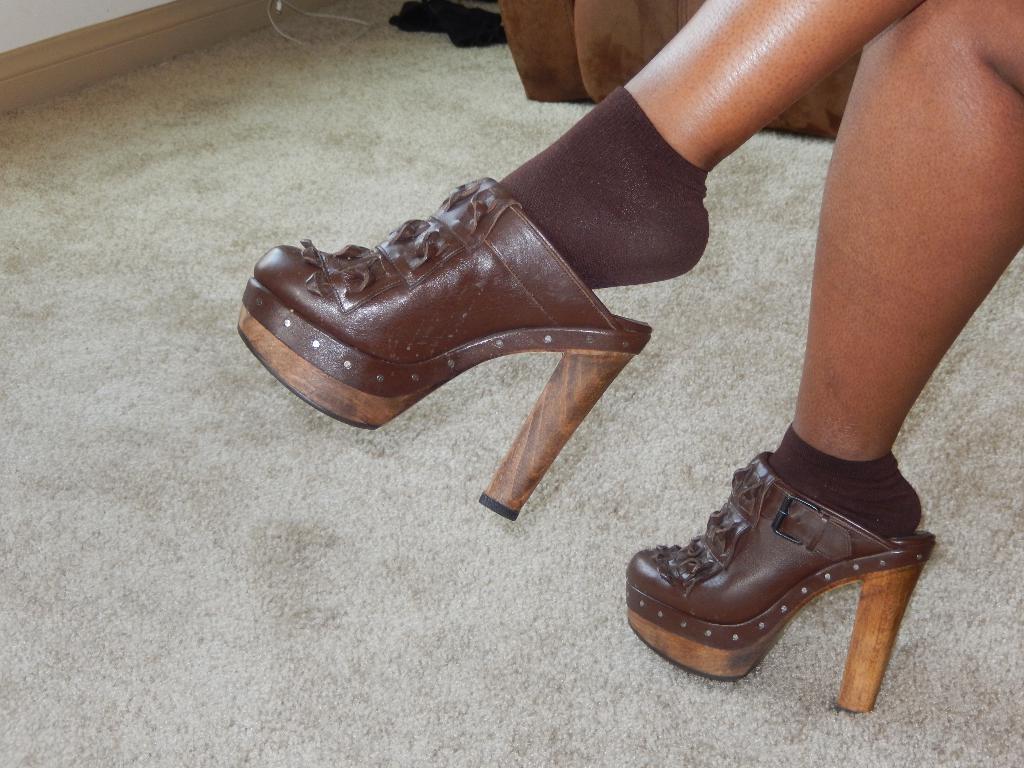Describe this image in one or two sentences. In this image I can see a pair of heels and also I can see a leg of a person. 